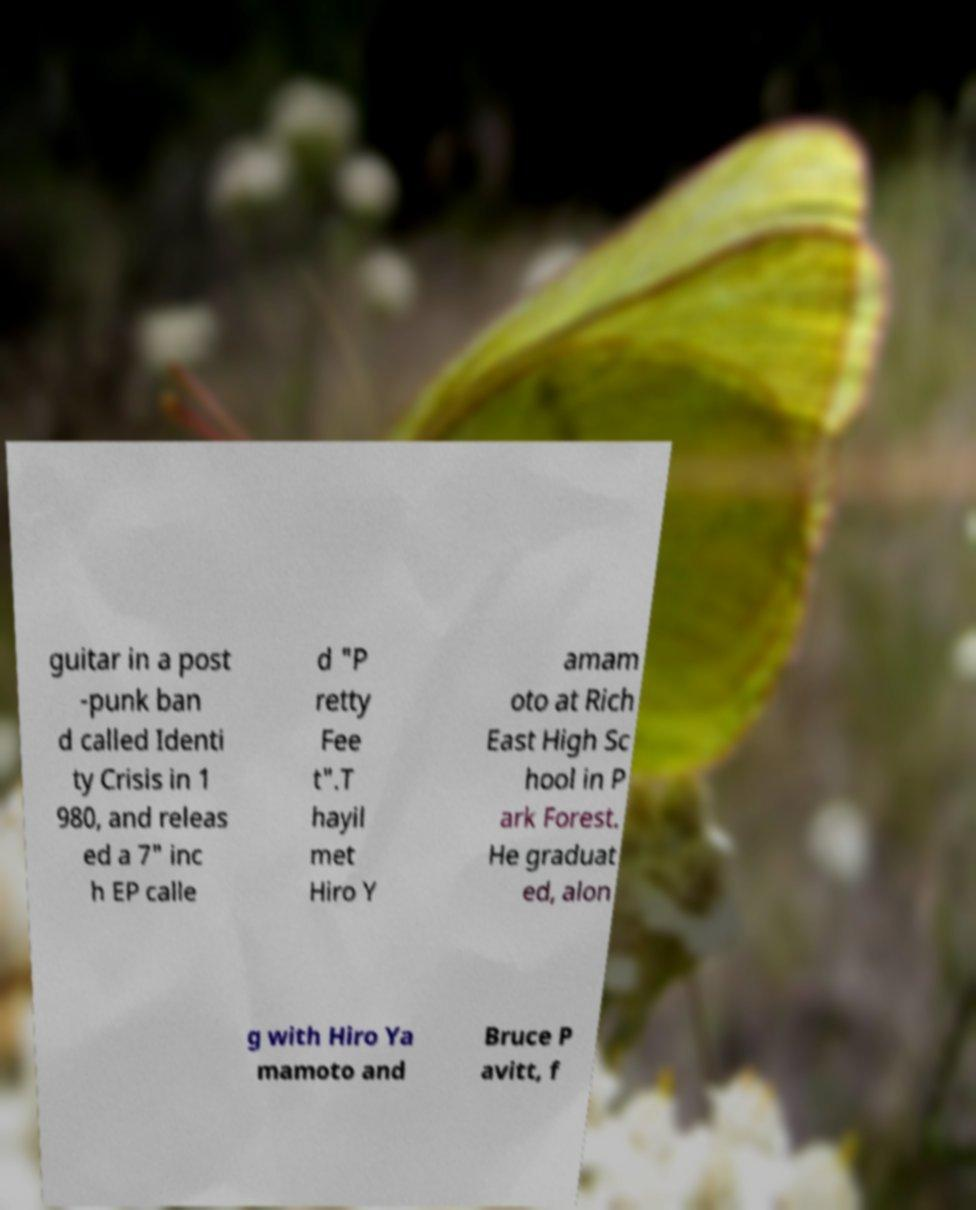There's text embedded in this image that I need extracted. Can you transcribe it verbatim? guitar in a post -punk ban d called Identi ty Crisis in 1 980, and releas ed a 7" inc h EP calle d "P retty Fee t".T hayil met Hiro Y amam oto at Rich East High Sc hool in P ark Forest. He graduat ed, alon g with Hiro Ya mamoto and Bruce P avitt, f 